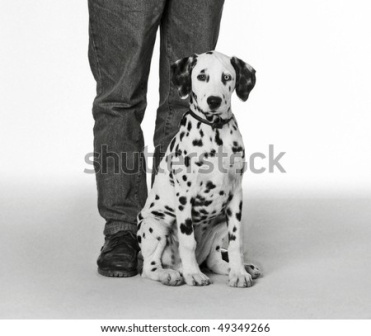Describe the following image. The image portrays a heartwarming moment featuring a Dalmatian puppy and a person. The Dalmatian, characterized by its distinctive black spots on a white coat, sits obediently next to the individual's legs. The person is wearing jeans and black shoes, casting a casual vibe to the scene. The puppy appears to be gazing up, possibly towards the person or the camera, evoking a sense of curiosity and anticipation. Set against a plain white background, the focus is drawn entirely to the puppy and the person, enhancing the simplicity and emotional depth of the composition. The monochrome color scheme imparts a timeless quality to the photograph. Despite the absence of vibrant colors, the image is rich with details and sentiments, encapsulating the bond between humans and their pets in a powerful, yet understated manner. 